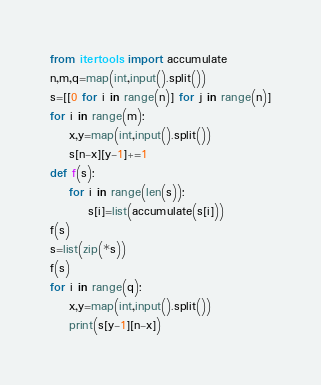<code> <loc_0><loc_0><loc_500><loc_500><_Python_>from itertools import accumulate
n,m,q=map(int,input().split())
s=[[0 for i in range(n)] for j in range(n)]
for i in range(m):
    x,y=map(int,input().split())
    s[n-x][y-1]+=1
def f(s):
    for i in range(len(s)):
        s[i]=list(accumulate(s[i]))
f(s)
s=list(zip(*s))
f(s)
for i in range(q):
    x,y=map(int,input().split())
    print(s[y-1][n-x])</code> 